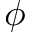Convert formula to latex. <formula><loc_0><loc_0><loc_500><loc_500>\phi</formula> 